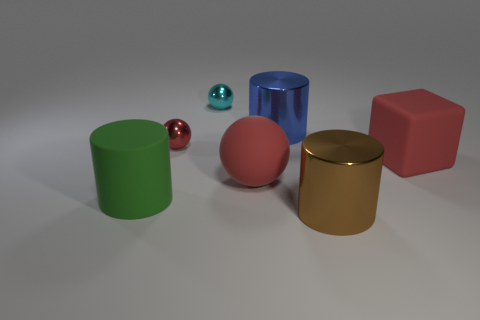Subtract all small red metal balls. How many balls are left? 2 Subtract all red blocks. How many red spheres are left? 2 Add 1 metallic spheres. How many objects exist? 8 Subtract all balls. How many objects are left? 4 Subtract all gray cylinders. Subtract all gray spheres. How many cylinders are left? 3 Add 5 green objects. How many green objects exist? 6 Subtract 0 blue cubes. How many objects are left? 7 Subtract all small cyan things. Subtract all small cyan spheres. How many objects are left? 5 Add 1 large red rubber cubes. How many large red rubber cubes are left? 2 